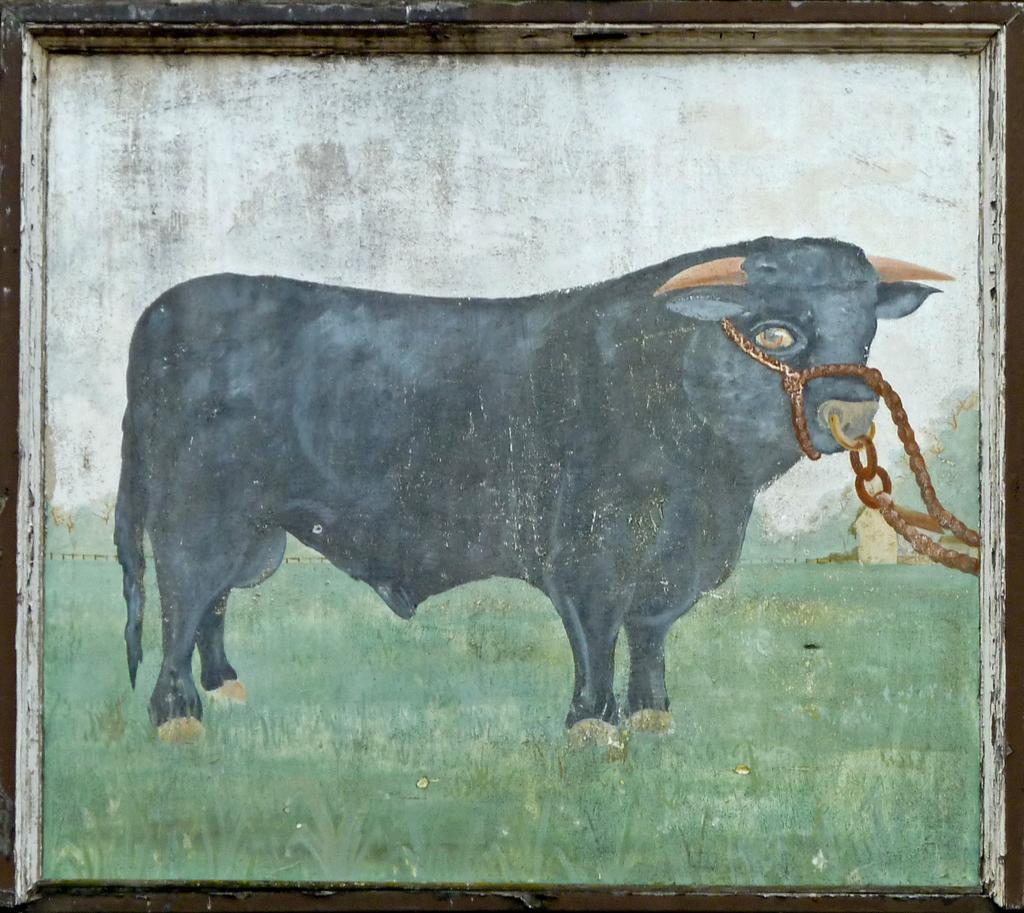What is the main subject of the image? The image contains a painting. What is depicted in the painting? The painting depicts a buffalo. What type of environment is shown at the bottom of the painting? There is grass at the bottom of the painting. What type of frame surrounds the painting? The painting has a wooden frame. Can you tell me how many people are involved in the discussion in the image? There is no discussion present in the image; it features a painting of a buffalo with grass at the bottom and a wooden frame. How does the buffalo help the artist in the image? The image does not depict the buffalo helping the artist; it is a static representation of a buffalo in a grassy environment. 